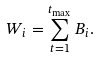<formula> <loc_0><loc_0><loc_500><loc_500>W _ { i } = \sum _ { t = 1 } ^ { t _ { \max } } B _ { i } .</formula> 